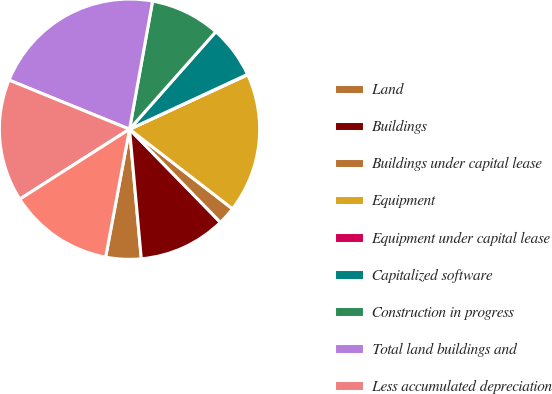Convert chart to OTSL. <chart><loc_0><loc_0><loc_500><loc_500><pie_chart><fcel>Land<fcel>Buildings<fcel>Buildings under capital lease<fcel>Equipment<fcel>Equipment under capital lease<fcel>Capitalized software<fcel>Construction in progress<fcel>Total land buildings and<fcel>Less accumulated depreciation<fcel>Total<nl><fcel>4.38%<fcel>10.86%<fcel>2.22%<fcel>17.35%<fcel>0.05%<fcel>6.54%<fcel>8.7%<fcel>21.67%<fcel>15.19%<fcel>13.03%<nl></chart> 